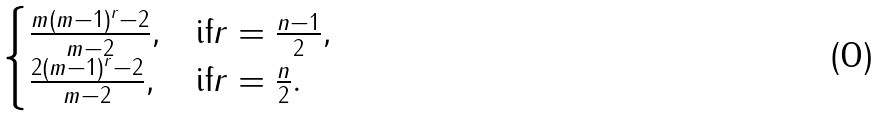<formula> <loc_0><loc_0><loc_500><loc_500>\begin{cases} \frac { m ( m - 1 ) ^ { r } - 2 } { m - 2 } , & \text {if} r = \frac { n - 1 } { 2 } , \\ \frac { 2 ( m - 1 ) ^ { r } - 2 } { m - 2 } , & \text {if} r = \frac { n } { 2 } . \end{cases}</formula> 